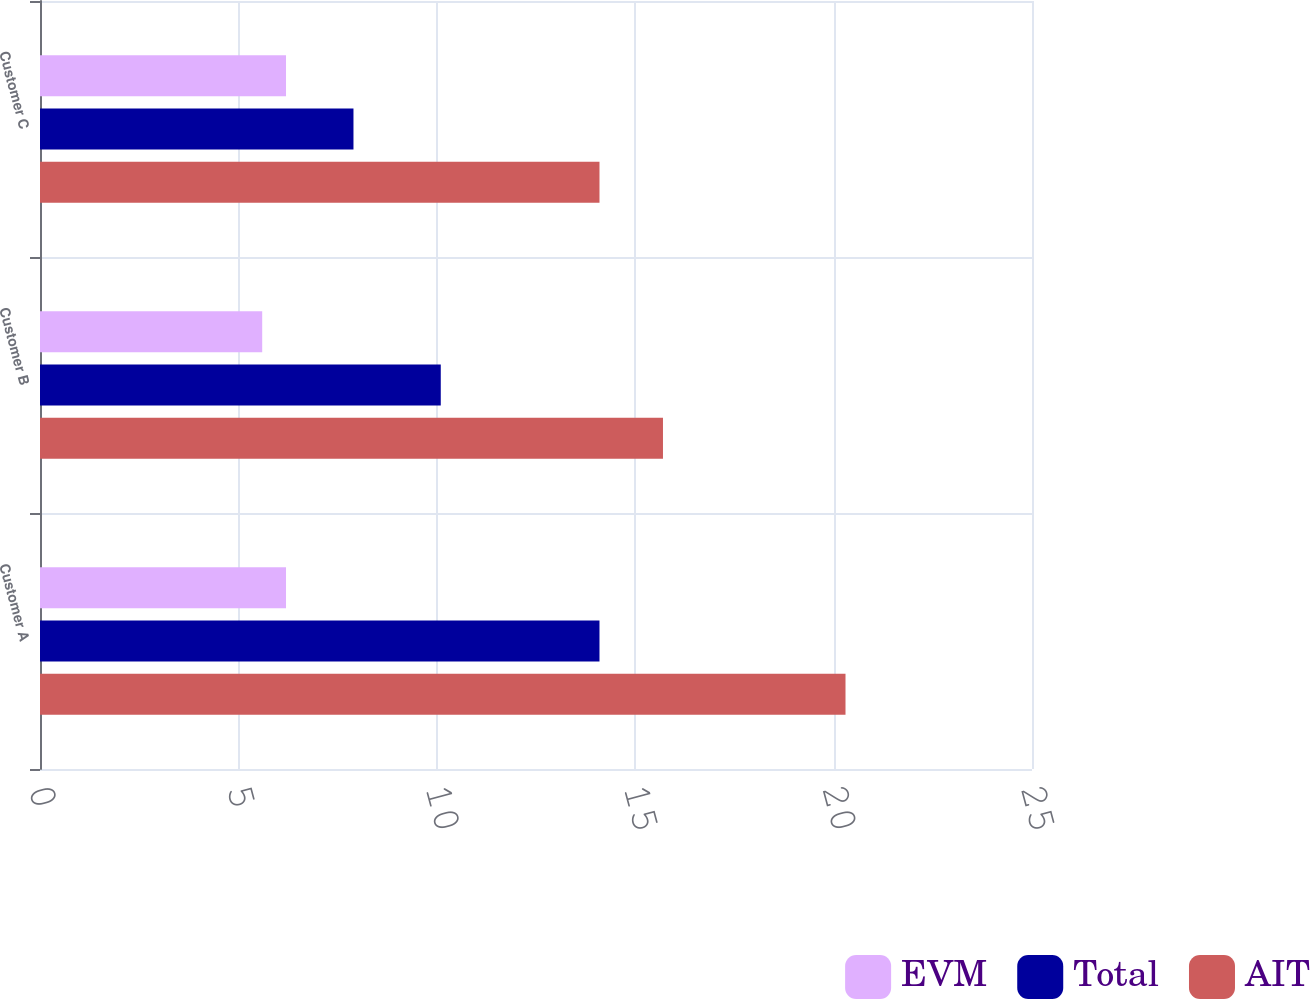Convert chart to OTSL. <chart><loc_0><loc_0><loc_500><loc_500><stacked_bar_chart><ecel><fcel>Customer A<fcel>Customer B<fcel>Customer C<nl><fcel>EVM<fcel>6.2<fcel>5.6<fcel>6.2<nl><fcel>Total<fcel>14.1<fcel>10.1<fcel>7.9<nl><fcel>AIT<fcel>20.3<fcel>15.7<fcel>14.1<nl></chart> 